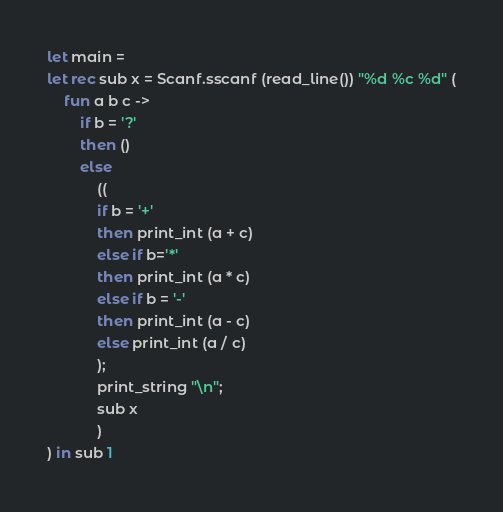Convert code to text. <code><loc_0><loc_0><loc_500><loc_500><_OCaml_>let main =
let rec sub x = Scanf.sscanf (read_line()) "%d %c %d" (
    fun a b c ->
        if b = '?'
        then ()
        else
            ((
            if b = '+'
            then print_int (a + c)
            else if b='*'
            then print_int (a * c)
            else if b = '-'
            then print_int (a - c)
            else print_int (a / c)
            );
            print_string "\n";
            sub x
            )
) in sub 1</code> 